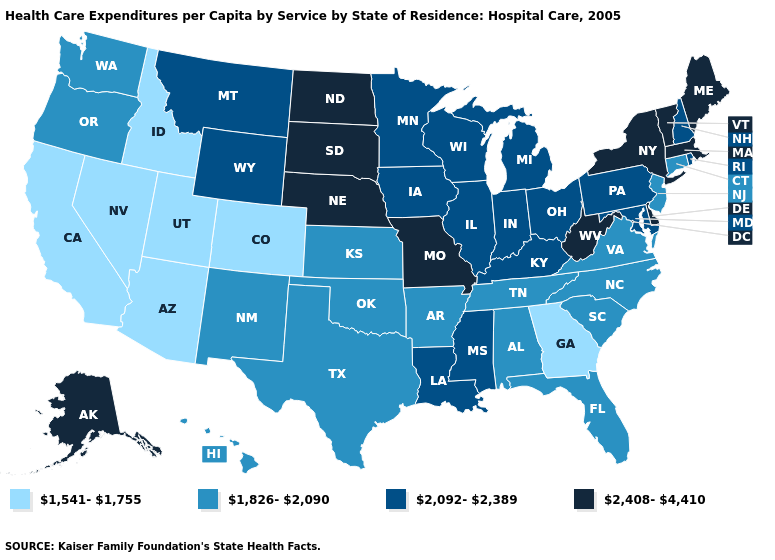Among the states that border Vermont , does New Hampshire have the lowest value?
Keep it brief. Yes. What is the highest value in the West ?
Be succinct. 2,408-4,410. Does the first symbol in the legend represent the smallest category?
Write a very short answer. Yes. Does Ohio have the lowest value in the MidWest?
Concise answer only. No. Name the states that have a value in the range 2,092-2,389?
Give a very brief answer. Illinois, Indiana, Iowa, Kentucky, Louisiana, Maryland, Michigan, Minnesota, Mississippi, Montana, New Hampshire, Ohio, Pennsylvania, Rhode Island, Wisconsin, Wyoming. What is the value of Oregon?
Concise answer only. 1,826-2,090. Name the states that have a value in the range 1,541-1,755?
Give a very brief answer. Arizona, California, Colorado, Georgia, Idaho, Nevada, Utah. Which states have the highest value in the USA?
Keep it brief. Alaska, Delaware, Maine, Massachusetts, Missouri, Nebraska, New York, North Dakota, South Dakota, Vermont, West Virginia. Does North Dakota have the highest value in the USA?
Give a very brief answer. Yes. Does New York have the lowest value in the USA?
Answer briefly. No. Does Delaware have the highest value in the USA?
Short answer required. Yes. Among the states that border Minnesota , does Wisconsin have the lowest value?
Quick response, please. Yes. Does West Virginia have the highest value in the South?
Short answer required. Yes. Name the states that have a value in the range 2,408-4,410?
Answer briefly. Alaska, Delaware, Maine, Massachusetts, Missouri, Nebraska, New York, North Dakota, South Dakota, Vermont, West Virginia. Does North Dakota have a lower value than Georgia?
Write a very short answer. No. 